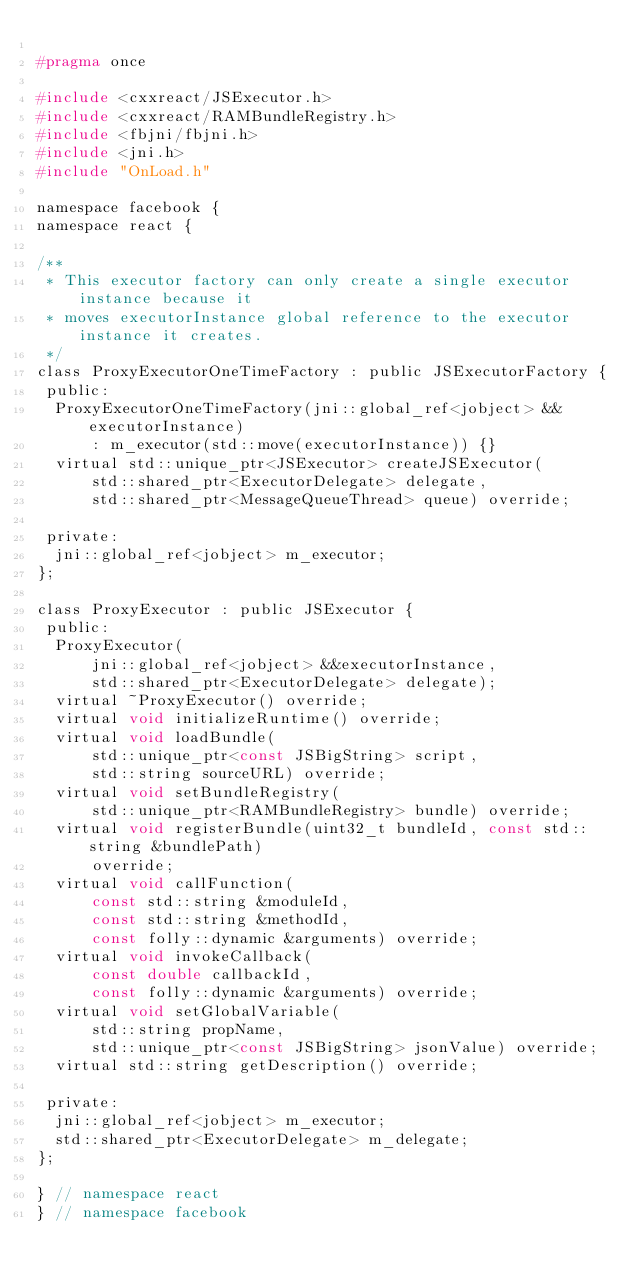Convert code to text. <code><loc_0><loc_0><loc_500><loc_500><_C_>
#pragma once

#include <cxxreact/JSExecutor.h>
#include <cxxreact/RAMBundleRegistry.h>
#include <fbjni/fbjni.h>
#include <jni.h>
#include "OnLoad.h"

namespace facebook {
namespace react {

/**
 * This executor factory can only create a single executor instance because it
 * moves executorInstance global reference to the executor instance it creates.
 */
class ProxyExecutorOneTimeFactory : public JSExecutorFactory {
 public:
  ProxyExecutorOneTimeFactory(jni::global_ref<jobject> &&executorInstance)
      : m_executor(std::move(executorInstance)) {}
  virtual std::unique_ptr<JSExecutor> createJSExecutor(
      std::shared_ptr<ExecutorDelegate> delegate,
      std::shared_ptr<MessageQueueThread> queue) override;

 private:
  jni::global_ref<jobject> m_executor;
};

class ProxyExecutor : public JSExecutor {
 public:
  ProxyExecutor(
      jni::global_ref<jobject> &&executorInstance,
      std::shared_ptr<ExecutorDelegate> delegate);
  virtual ~ProxyExecutor() override;
  virtual void initializeRuntime() override;
  virtual void loadBundle(
      std::unique_ptr<const JSBigString> script,
      std::string sourceURL) override;
  virtual void setBundleRegistry(
      std::unique_ptr<RAMBundleRegistry> bundle) override;
  virtual void registerBundle(uint32_t bundleId, const std::string &bundlePath)
      override;
  virtual void callFunction(
      const std::string &moduleId,
      const std::string &methodId,
      const folly::dynamic &arguments) override;
  virtual void invokeCallback(
      const double callbackId,
      const folly::dynamic &arguments) override;
  virtual void setGlobalVariable(
      std::string propName,
      std::unique_ptr<const JSBigString> jsonValue) override;
  virtual std::string getDescription() override;

 private:
  jni::global_ref<jobject> m_executor;
  std::shared_ptr<ExecutorDelegate> m_delegate;
};

} // namespace react
} // namespace facebook
</code> 